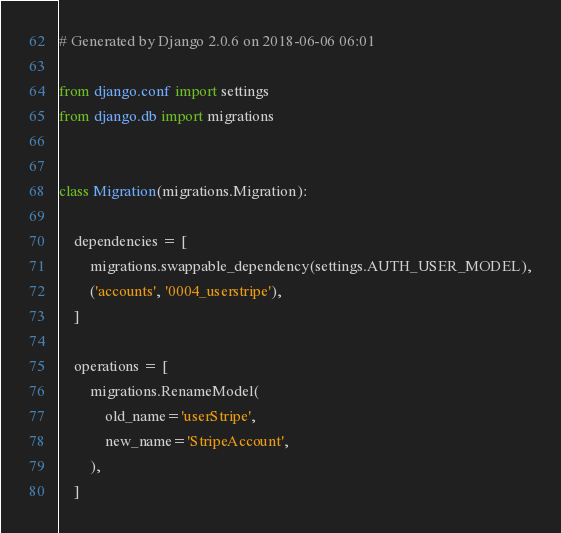Convert code to text. <code><loc_0><loc_0><loc_500><loc_500><_Python_># Generated by Django 2.0.6 on 2018-06-06 06:01

from django.conf import settings
from django.db import migrations


class Migration(migrations.Migration):

    dependencies = [
        migrations.swappable_dependency(settings.AUTH_USER_MODEL),
        ('accounts', '0004_userstripe'),
    ]

    operations = [
        migrations.RenameModel(
            old_name='userStripe',
            new_name='StripeAccount',
        ),
    ]
</code> 